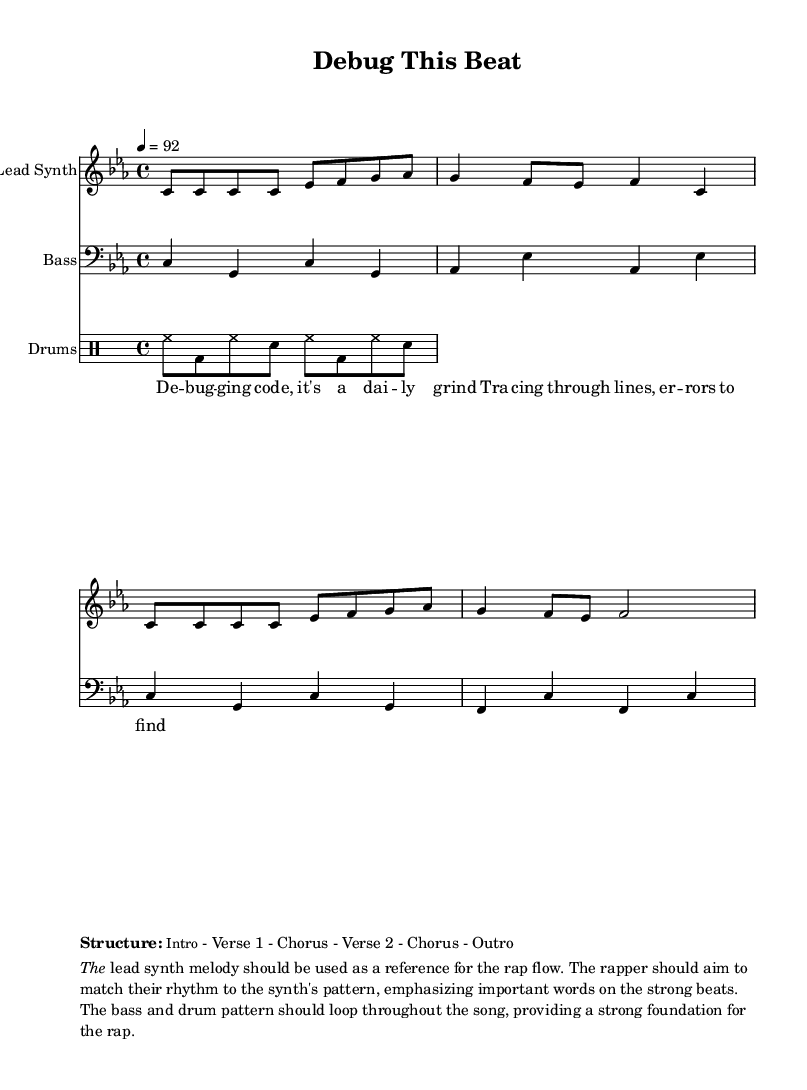What is the key signature of this music? The key signature is determined by the number of sharps or flats indicated at the beginning of the staff. In this case, the key signature shows B flat and E flat, which corresponds to C minor.
Answer: C minor What is the time signature of this music? The time signature is indicated at the beginning of the staff following the key signature. It shows four beats per measure with a quarter note receiving one beat, which is represented as 4/4.
Answer: 4/4 What is the tempo marking of this music? The tempo marking indicates the speed of the music and is usually found at the top of the score. In this case, it states a tempo of 92 beats per minute, where the quarter note equals 92.
Answer: 92 What instrument is playing the lead synth? The instrument for the lead synth is specified in the staff name written at the beginning of the staff. It is labeled as "Lead Synth," indicating that this part is performed by a synthesizer.
Answer: Lead Synth How many verses are in the structure of this music? The structure is laid out in a detailed format, indicating the order of the sections. It lists intro, chorus, and two verses, thus totaling two distinct verses.
Answer: 2 What type of music does this score represent? The lyrical content, structure, and the rhythmic style indicated suggest that the score is composed for the hip-hop genre, which typically features rapping.
Answer: Rap 